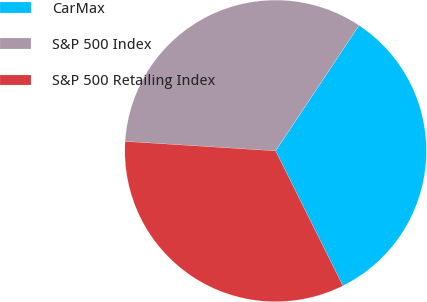<chart> <loc_0><loc_0><loc_500><loc_500><pie_chart><fcel>CarMax<fcel>S&P 500 Index<fcel>S&P 500 Retailing Index<nl><fcel>33.3%<fcel>33.33%<fcel>33.37%<nl></chart> 